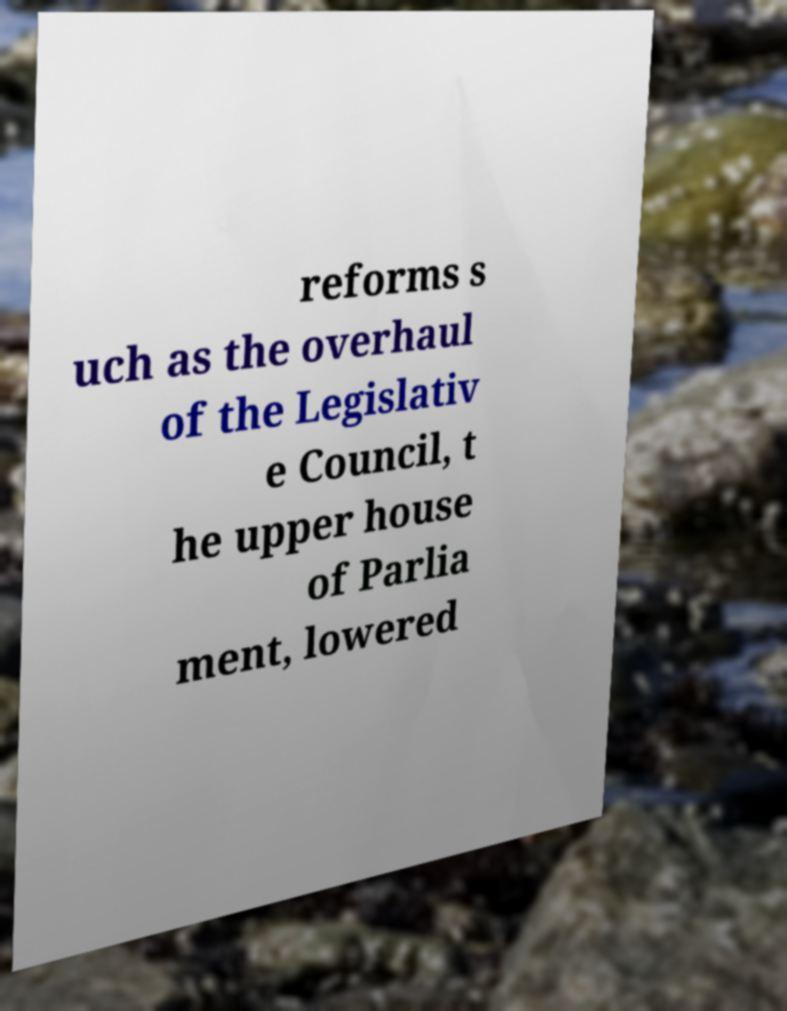Can you read and provide the text displayed in the image?This photo seems to have some interesting text. Can you extract and type it out for me? reforms s uch as the overhaul of the Legislativ e Council, t he upper house of Parlia ment, lowered 